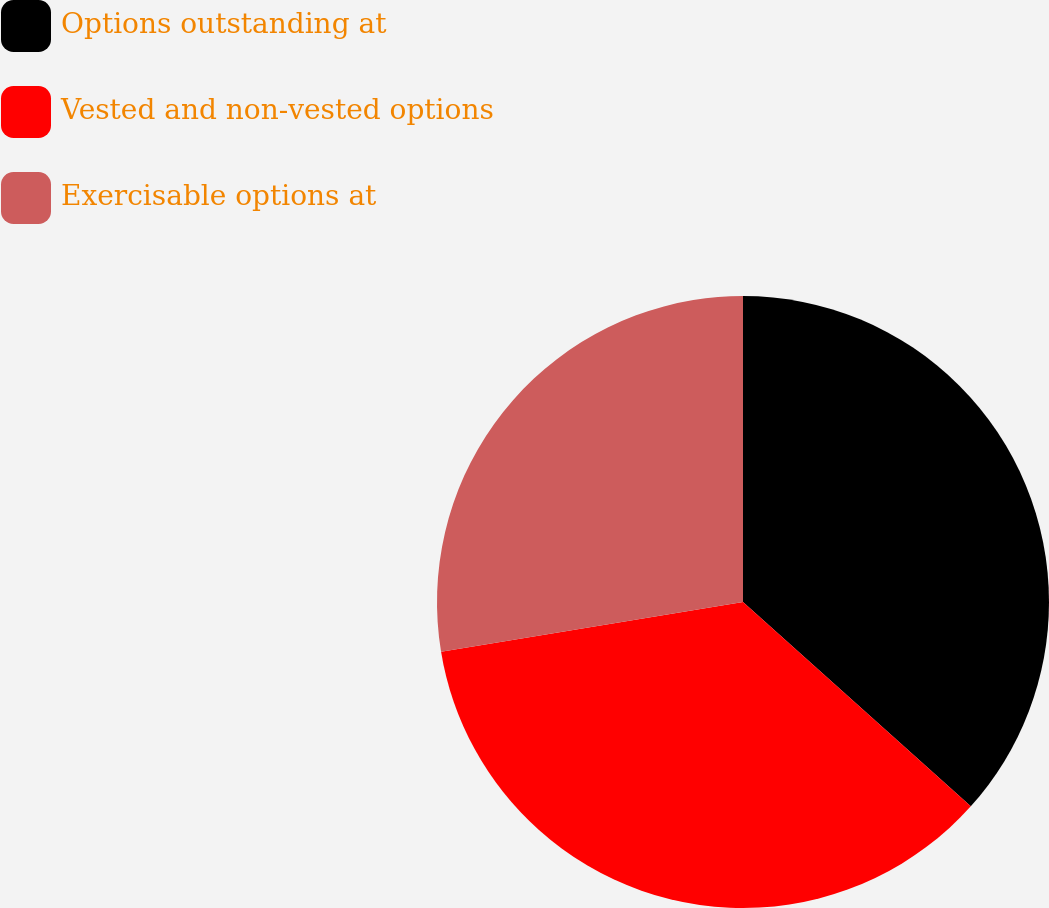<chart> <loc_0><loc_0><loc_500><loc_500><pie_chart><fcel>Options outstanding at<fcel>Vested and non-vested options<fcel>Exercisable options at<nl><fcel>36.64%<fcel>35.77%<fcel>27.6%<nl></chart> 